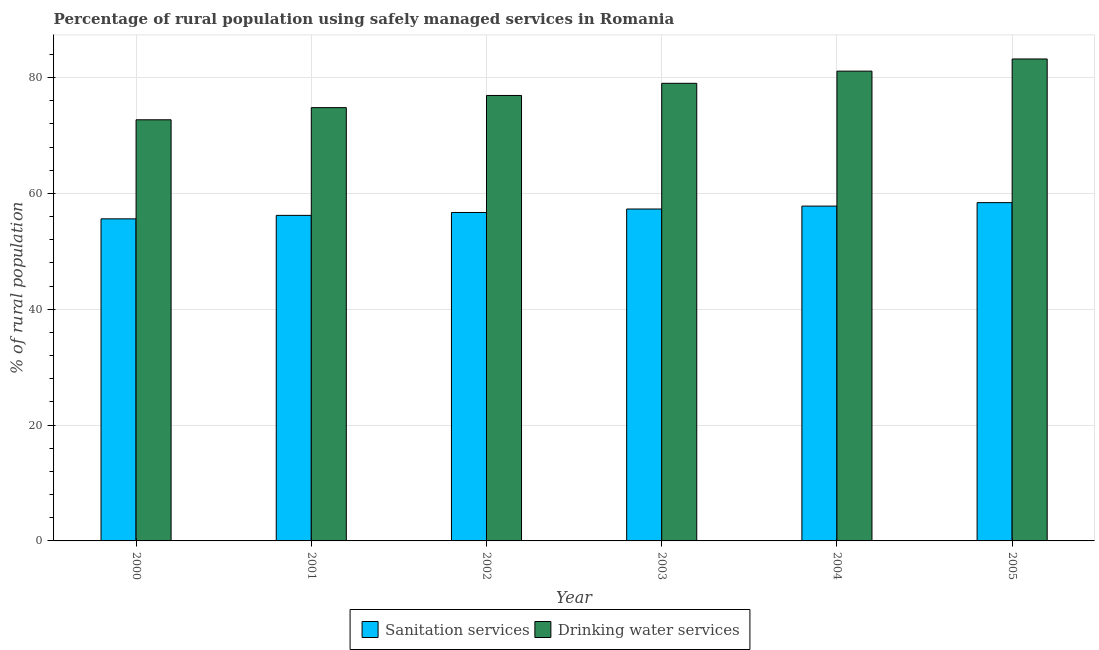How many different coloured bars are there?
Offer a terse response. 2. How many groups of bars are there?
Make the answer very short. 6. Are the number of bars per tick equal to the number of legend labels?
Your response must be concise. Yes. What is the label of the 1st group of bars from the left?
Offer a very short reply. 2000. In how many cases, is the number of bars for a given year not equal to the number of legend labels?
Ensure brevity in your answer.  0. What is the percentage of rural population who used drinking water services in 2001?
Give a very brief answer. 74.8. Across all years, what is the maximum percentage of rural population who used sanitation services?
Provide a short and direct response. 58.4. Across all years, what is the minimum percentage of rural population who used sanitation services?
Offer a very short reply. 55.6. In which year was the percentage of rural population who used drinking water services minimum?
Give a very brief answer. 2000. What is the total percentage of rural population who used drinking water services in the graph?
Provide a succinct answer. 467.7. What is the difference between the percentage of rural population who used sanitation services in 2004 and the percentage of rural population who used drinking water services in 2002?
Provide a succinct answer. 1.1. What is the average percentage of rural population who used drinking water services per year?
Your response must be concise. 77.95. In the year 2003, what is the difference between the percentage of rural population who used sanitation services and percentage of rural population who used drinking water services?
Provide a short and direct response. 0. What is the ratio of the percentage of rural population who used drinking water services in 2000 to that in 2004?
Your answer should be compact. 0.9. Is the difference between the percentage of rural population who used drinking water services in 2000 and 2002 greater than the difference between the percentage of rural population who used sanitation services in 2000 and 2002?
Offer a very short reply. No. What is the difference between the highest and the second highest percentage of rural population who used sanitation services?
Offer a terse response. 0.6. Is the sum of the percentage of rural population who used sanitation services in 2000 and 2005 greater than the maximum percentage of rural population who used drinking water services across all years?
Offer a very short reply. Yes. What does the 1st bar from the left in 2000 represents?
Your answer should be very brief. Sanitation services. What does the 1st bar from the right in 2002 represents?
Offer a very short reply. Drinking water services. How many bars are there?
Ensure brevity in your answer.  12. Does the graph contain any zero values?
Offer a very short reply. No. Does the graph contain grids?
Keep it short and to the point. Yes. Where does the legend appear in the graph?
Ensure brevity in your answer.  Bottom center. What is the title of the graph?
Give a very brief answer. Percentage of rural population using safely managed services in Romania. Does "Food and tobacco" appear as one of the legend labels in the graph?
Ensure brevity in your answer.  No. What is the label or title of the X-axis?
Make the answer very short. Year. What is the label or title of the Y-axis?
Offer a terse response. % of rural population. What is the % of rural population in Sanitation services in 2000?
Your answer should be compact. 55.6. What is the % of rural population of Drinking water services in 2000?
Offer a very short reply. 72.7. What is the % of rural population of Sanitation services in 2001?
Provide a succinct answer. 56.2. What is the % of rural population of Drinking water services in 2001?
Your answer should be very brief. 74.8. What is the % of rural population of Sanitation services in 2002?
Keep it short and to the point. 56.7. What is the % of rural population in Drinking water services in 2002?
Your answer should be very brief. 76.9. What is the % of rural population of Sanitation services in 2003?
Give a very brief answer. 57.3. What is the % of rural population of Drinking water services in 2003?
Provide a succinct answer. 79. What is the % of rural population of Sanitation services in 2004?
Give a very brief answer. 57.8. What is the % of rural population of Drinking water services in 2004?
Offer a very short reply. 81.1. What is the % of rural population of Sanitation services in 2005?
Offer a terse response. 58.4. What is the % of rural population in Drinking water services in 2005?
Offer a terse response. 83.2. Across all years, what is the maximum % of rural population of Sanitation services?
Your response must be concise. 58.4. Across all years, what is the maximum % of rural population in Drinking water services?
Your answer should be compact. 83.2. Across all years, what is the minimum % of rural population of Sanitation services?
Your answer should be compact. 55.6. Across all years, what is the minimum % of rural population in Drinking water services?
Give a very brief answer. 72.7. What is the total % of rural population in Sanitation services in the graph?
Your answer should be very brief. 342. What is the total % of rural population in Drinking water services in the graph?
Offer a very short reply. 467.7. What is the difference between the % of rural population of Sanitation services in 2000 and that in 2001?
Ensure brevity in your answer.  -0.6. What is the difference between the % of rural population of Drinking water services in 2000 and that in 2001?
Keep it short and to the point. -2.1. What is the difference between the % of rural population in Drinking water services in 2000 and that in 2003?
Ensure brevity in your answer.  -6.3. What is the difference between the % of rural population of Sanitation services in 2000 and that in 2004?
Your response must be concise. -2.2. What is the difference between the % of rural population in Drinking water services in 2000 and that in 2004?
Offer a terse response. -8.4. What is the difference between the % of rural population in Sanitation services in 2000 and that in 2005?
Offer a very short reply. -2.8. What is the difference between the % of rural population in Drinking water services in 2000 and that in 2005?
Give a very brief answer. -10.5. What is the difference between the % of rural population of Sanitation services in 2001 and that in 2002?
Your answer should be very brief. -0.5. What is the difference between the % of rural population in Drinking water services in 2001 and that in 2002?
Your response must be concise. -2.1. What is the difference between the % of rural population of Sanitation services in 2001 and that in 2004?
Give a very brief answer. -1.6. What is the difference between the % of rural population of Sanitation services in 2001 and that in 2005?
Keep it short and to the point. -2.2. What is the difference between the % of rural population of Drinking water services in 2001 and that in 2005?
Provide a succinct answer. -8.4. What is the difference between the % of rural population of Drinking water services in 2002 and that in 2003?
Offer a terse response. -2.1. What is the difference between the % of rural population of Sanitation services in 2002 and that in 2004?
Keep it short and to the point. -1.1. What is the difference between the % of rural population of Drinking water services in 2002 and that in 2004?
Keep it short and to the point. -4.2. What is the difference between the % of rural population of Drinking water services in 2002 and that in 2005?
Give a very brief answer. -6.3. What is the difference between the % of rural population of Sanitation services in 2003 and that in 2005?
Make the answer very short. -1.1. What is the difference between the % of rural population in Sanitation services in 2004 and that in 2005?
Your answer should be compact. -0.6. What is the difference between the % of rural population of Drinking water services in 2004 and that in 2005?
Offer a very short reply. -2.1. What is the difference between the % of rural population in Sanitation services in 2000 and the % of rural population in Drinking water services in 2001?
Your response must be concise. -19.2. What is the difference between the % of rural population in Sanitation services in 2000 and the % of rural population in Drinking water services in 2002?
Make the answer very short. -21.3. What is the difference between the % of rural population in Sanitation services in 2000 and the % of rural population in Drinking water services in 2003?
Offer a terse response. -23.4. What is the difference between the % of rural population of Sanitation services in 2000 and the % of rural population of Drinking water services in 2004?
Offer a very short reply. -25.5. What is the difference between the % of rural population of Sanitation services in 2000 and the % of rural population of Drinking water services in 2005?
Keep it short and to the point. -27.6. What is the difference between the % of rural population in Sanitation services in 2001 and the % of rural population in Drinking water services in 2002?
Provide a short and direct response. -20.7. What is the difference between the % of rural population in Sanitation services in 2001 and the % of rural population in Drinking water services in 2003?
Provide a short and direct response. -22.8. What is the difference between the % of rural population of Sanitation services in 2001 and the % of rural population of Drinking water services in 2004?
Your answer should be compact. -24.9. What is the difference between the % of rural population of Sanitation services in 2001 and the % of rural population of Drinking water services in 2005?
Provide a succinct answer. -27. What is the difference between the % of rural population of Sanitation services in 2002 and the % of rural population of Drinking water services in 2003?
Make the answer very short. -22.3. What is the difference between the % of rural population of Sanitation services in 2002 and the % of rural population of Drinking water services in 2004?
Give a very brief answer. -24.4. What is the difference between the % of rural population in Sanitation services in 2002 and the % of rural population in Drinking water services in 2005?
Your answer should be compact. -26.5. What is the difference between the % of rural population of Sanitation services in 2003 and the % of rural population of Drinking water services in 2004?
Offer a terse response. -23.8. What is the difference between the % of rural population of Sanitation services in 2003 and the % of rural population of Drinking water services in 2005?
Your answer should be very brief. -25.9. What is the difference between the % of rural population of Sanitation services in 2004 and the % of rural population of Drinking water services in 2005?
Keep it short and to the point. -25.4. What is the average % of rural population in Drinking water services per year?
Provide a short and direct response. 77.95. In the year 2000, what is the difference between the % of rural population in Sanitation services and % of rural population in Drinking water services?
Your answer should be compact. -17.1. In the year 2001, what is the difference between the % of rural population of Sanitation services and % of rural population of Drinking water services?
Your answer should be very brief. -18.6. In the year 2002, what is the difference between the % of rural population of Sanitation services and % of rural population of Drinking water services?
Your answer should be very brief. -20.2. In the year 2003, what is the difference between the % of rural population in Sanitation services and % of rural population in Drinking water services?
Offer a very short reply. -21.7. In the year 2004, what is the difference between the % of rural population of Sanitation services and % of rural population of Drinking water services?
Keep it short and to the point. -23.3. In the year 2005, what is the difference between the % of rural population of Sanitation services and % of rural population of Drinking water services?
Provide a succinct answer. -24.8. What is the ratio of the % of rural population in Sanitation services in 2000 to that in 2001?
Give a very brief answer. 0.99. What is the ratio of the % of rural population of Drinking water services in 2000 to that in 2001?
Offer a terse response. 0.97. What is the ratio of the % of rural population in Sanitation services in 2000 to that in 2002?
Keep it short and to the point. 0.98. What is the ratio of the % of rural population of Drinking water services in 2000 to that in 2002?
Keep it short and to the point. 0.95. What is the ratio of the % of rural population in Sanitation services in 2000 to that in 2003?
Your response must be concise. 0.97. What is the ratio of the % of rural population of Drinking water services in 2000 to that in 2003?
Offer a terse response. 0.92. What is the ratio of the % of rural population in Sanitation services in 2000 to that in 2004?
Give a very brief answer. 0.96. What is the ratio of the % of rural population of Drinking water services in 2000 to that in 2004?
Offer a terse response. 0.9. What is the ratio of the % of rural population of Sanitation services in 2000 to that in 2005?
Make the answer very short. 0.95. What is the ratio of the % of rural population of Drinking water services in 2000 to that in 2005?
Provide a succinct answer. 0.87. What is the ratio of the % of rural population of Drinking water services in 2001 to that in 2002?
Your answer should be compact. 0.97. What is the ratio of the % of rural population of Sanitation services in 2001 to that in 2003?
Offer a very short reply. 0.98. What is the ratio of the % of rural population in Drinking water services in 2001 to that in 2003?
Offer a terse response. 0.95. What is the ratio of the % of rural population of Sanitation services in 2001 to that in 2004?
Ensure brevity in your answer.  0.97. What is the ratio of the % of rural population in Drinking water services in 2001 to that in 2004?
Keep it short and to the point. 0.92. What is the ratio of the % of rural population in Sanitation services in 2001 to that in 2005?
Give a very brief answer. 0.96. What is the ratio of the % of rural population of Drinking water services in 2001 to that in 2005?
Offer a terse response. 0.9. What is the ratio of the % of rural population in Sanitation services in 2002 to that in 2003?
Provide a succinct answer. 0.99. What is the ratio of the % of rural population in Drinking water services in 2002 to that in 2003?
Your answer should be very brief. 0.97. What is the ratio of the % of rural population of Drinking water services in 2002 to that in 2004?
Your answer should be compact. 0.95. What is the ratio of the % of rural population of Sanitation services in 2002 to that in 2005?
Provide a succinct answer. 0.97. What is the ratio of the % of rural population in Drinking water services in 2002 to that in 2005?
Your answer should be very brief. 0.92. What is the ratio of the % of rural population in Drinking water services in 2003 to that in 2004?
Give a very brief answer. 0.97. What is the ratio of the % of rural population in Sanitation services in 2003 to that in 2005?
Your answer should be compact. 0.98. What is the ratio of the % of rural population of Drinking water services in 2003 to that in 2005?
Ensure brevity in your answer.  0.95. What is the ratio of the % of rural population of Drinking water services in 2004 to that in 2005?
Make the answer very short. 0.97. What is the difference between the highest and the second highest % of rural population of Sanitation services?
Your response must be concise. 0.6. What is the difference between the highest and the lowest % of rural population in Drinking water services?
Make the answer very short. 10.5. 